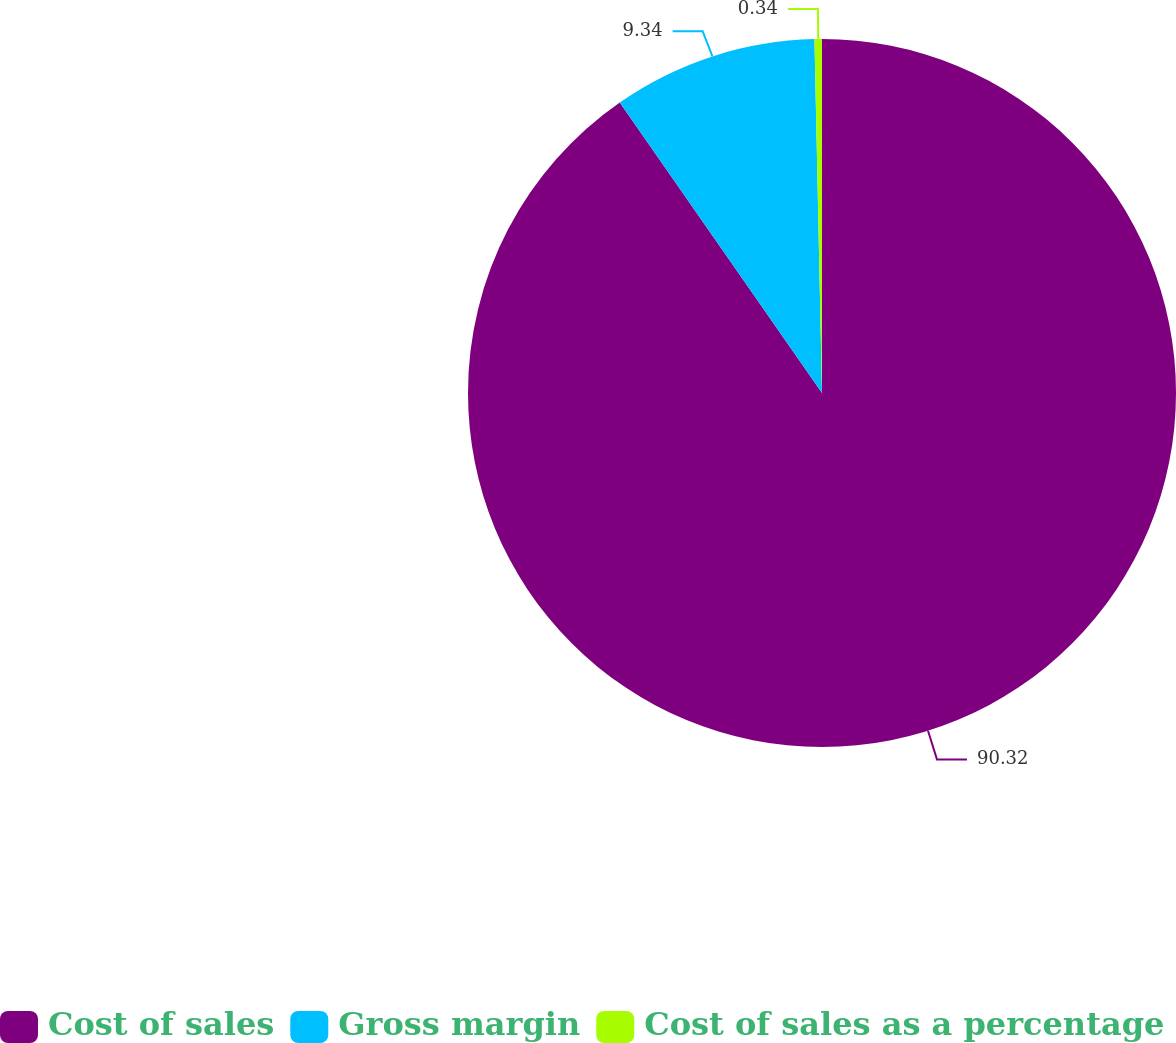<chart> <loc_0><loc_0><loc_500><loc_500><pie_chart><fcel>Cost of sales<fcel>Gross margin<fcel>Cost of sales as a percentage<nl><fcel>90.33%<fcel>9.34%<fcel>0.34%<nl></chart> 